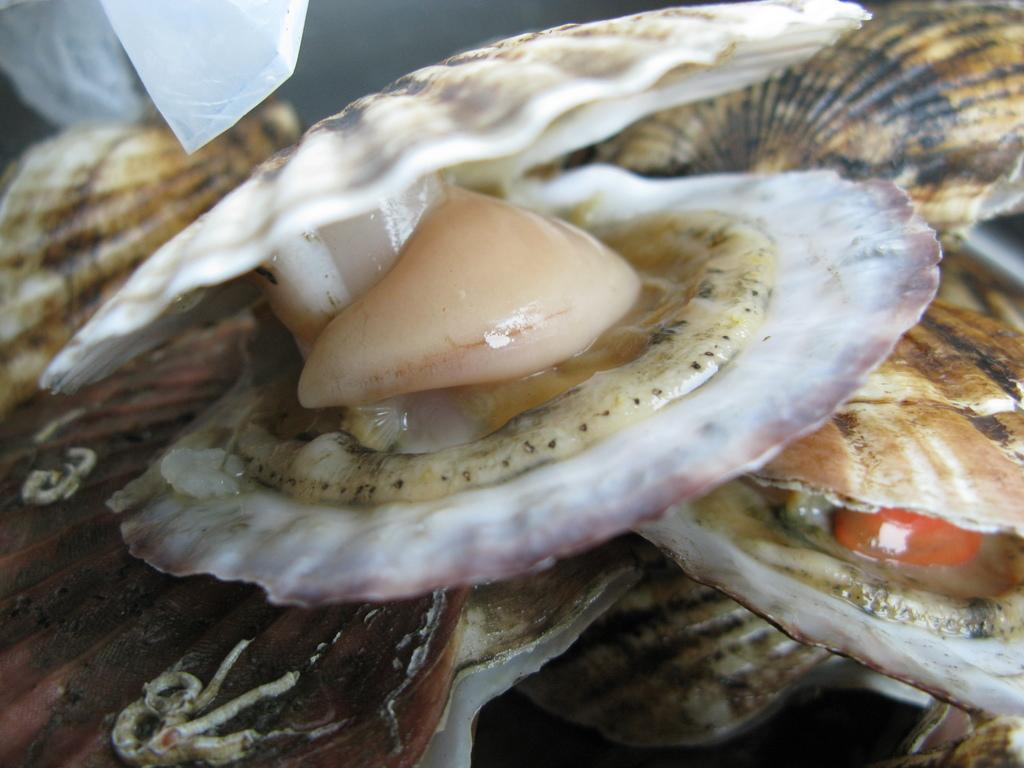What type of objects can be seen in the image? There are shells in the image. Can you describe the colors of the shells? The shells are in white and brown colors. What part of the shells is visible in the image? The inner part of the shells is visible in the image. Are there any dinosaurs visible in the image? No, there are no dinosaurs present in the image. 